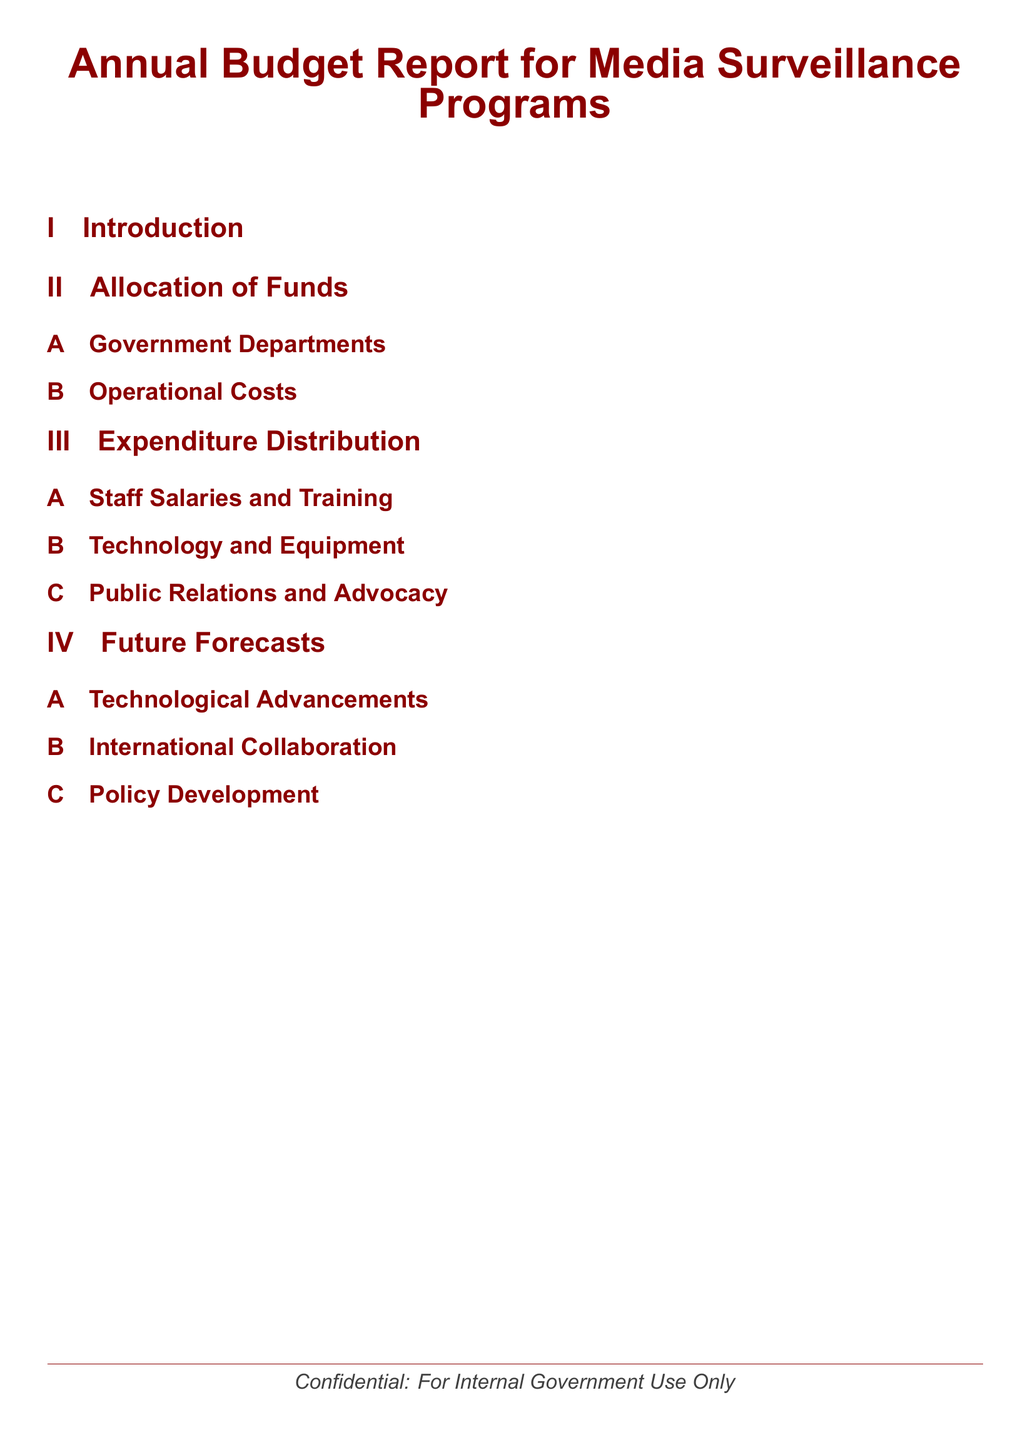what is the title of the document? The title is provided at the top center of the document.
Answer: Annual Budget Report for Media Surveillance Programs how many main sections are in the document? The document structure indicates three main sections.
Answer: 3 what is covered in the section on Allocation of Funds? The section includes subsections that specify the funding details for government departments and operational costs.
Answer: Government Departments, Operational Costs what type of expenditure is listed for staff? The document mentions specific use of funds allocated for personnel.
Answer: Salaries and Training what future aspect does the document forecast regarding technology? The future forecasts section outlines potential advancements that may impact processes.
Answer: Technological Advancements which subsection discusses collaboration with other entities? The document explicitly includes coordination with foreign organizations as a forecasted area.
Answer: International Collaboration what is the purpose of the document’s confidentiality note? The note indicates the level of accessibility and intended audience for the document.
Answer: For Internal Government Use Only 